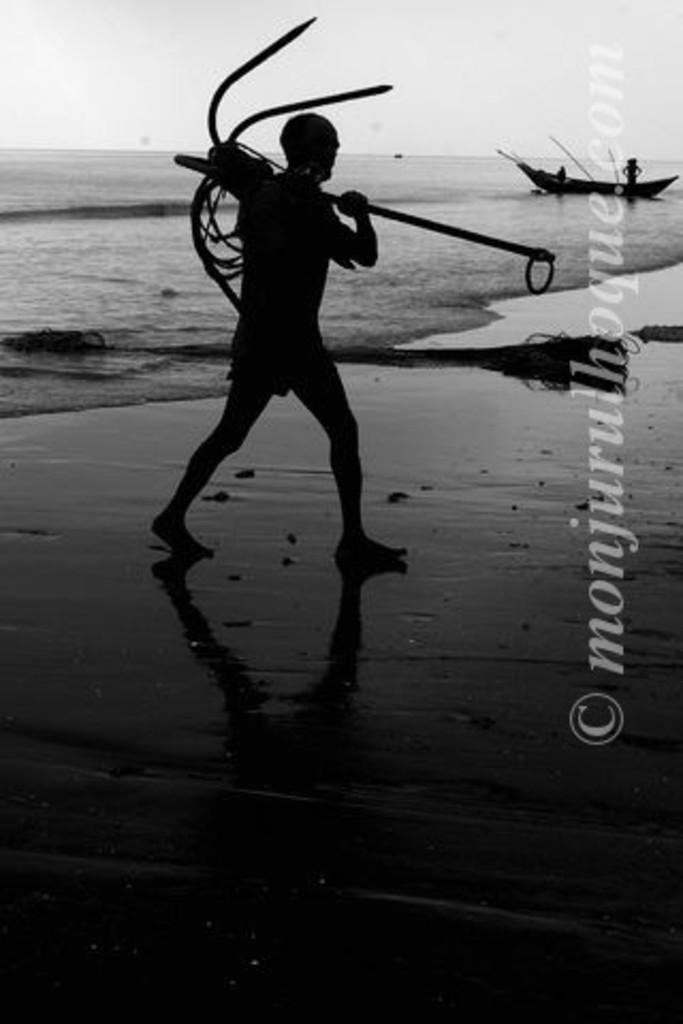<image>
Summarize the visual content of the image. A poster of a soldier on a beach by monjurulhoque.com 